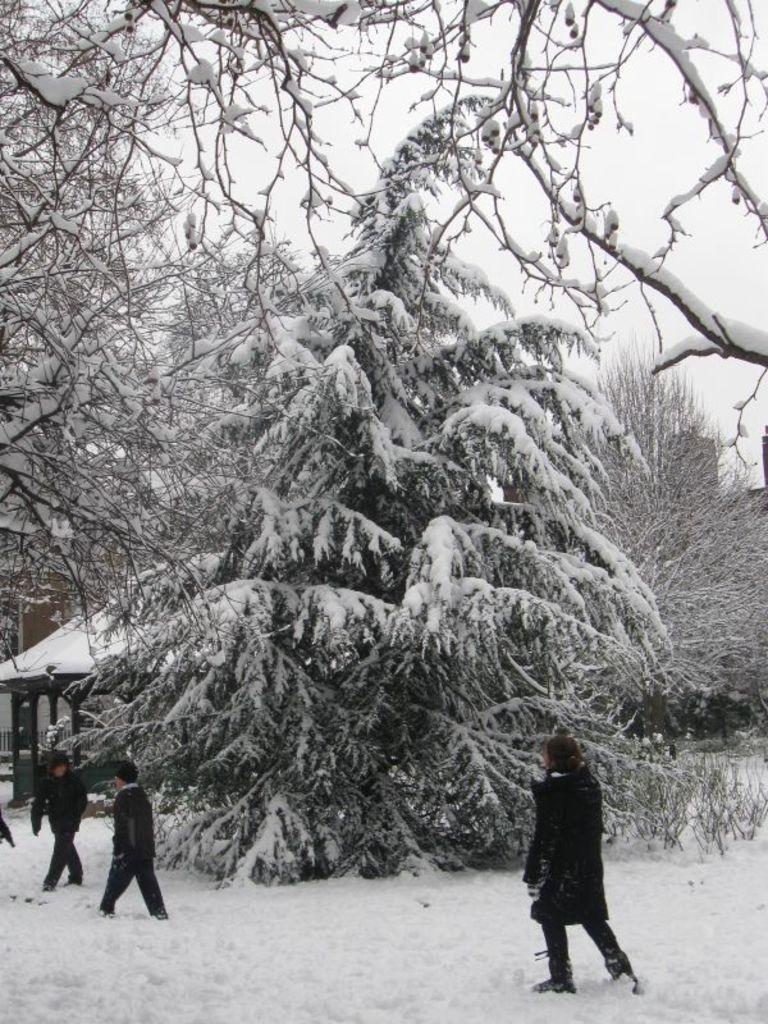What type of vegetation can be seen in the image? There are trees in the image. What is covering the trees in the image? There is snow on the trees. Are there any people present in the image? Yes, there are people standing in the image. What can be seen in the sky in the image? The sky is visible in the image. What type of bulb is being used to light up the train tracks in the image? There is no mention of a bulb or train tracks in the image; it features trees with snow and people standing nearby. 